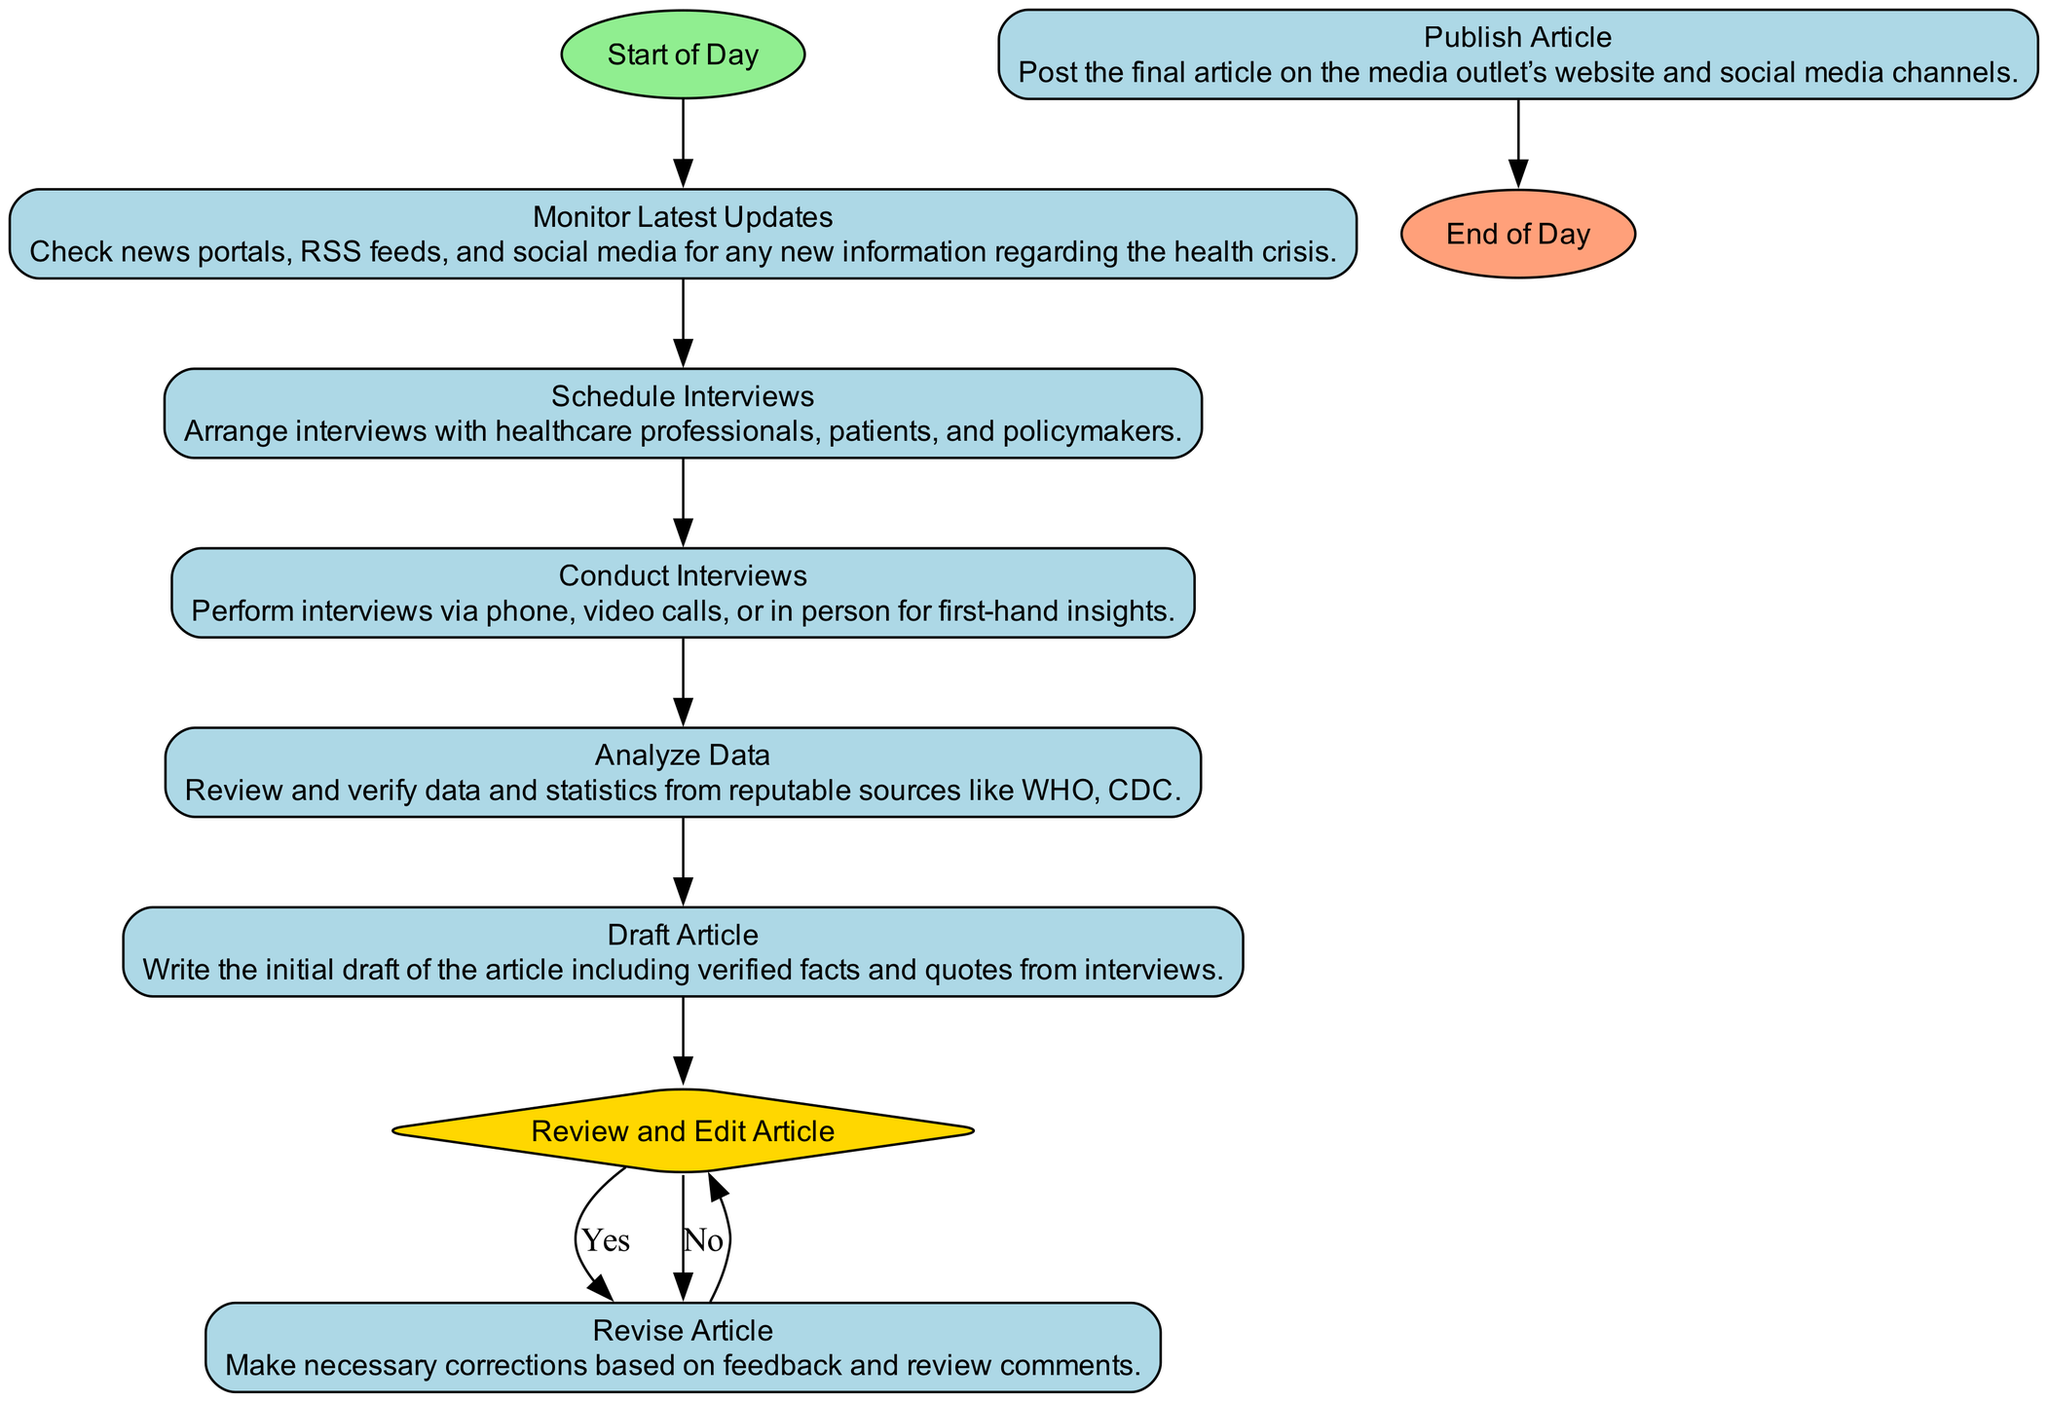What is the first activity in the diagram? The diagram starts with the "Start of Day" node, which indicates the beginning of the medical journalist's day. Hence, the first activity follows this starting point.
Answer: Start of Day How many activities are there in total? By counting each "Activity" type node in the diagram, we see that there are six activities: "Monitor Latest Updates," "Schedule Interviews," "Conduct Interviews," "Analyze Data," "Draft Article," and "Revise Article."
Answer: 6 What follows after "Analyze Data"? According to the flow of the diagram, after "Analyze Data," the next activity is "Draft Article." This indicates a sequential process where analysis leads to drafting.
Answer: Draft Article If the article needs revision, what is the next step? From the "Review and Edit Article" decision point, if the article needs revision, we go back to "Revise Article," indicating that revision is part of the editing process.
Answer: Revise Article What is the last action taken in the diagram? The terminal node of the diagram is "End of Day," which signifies that all activities have concluded. This represents the end point after publishing the article.
Answer: End of Day How many decision points are present in the diagram? There is only one decision point in the diagram, which is labeled "Review and Edit Article." This is where the decision to revise or approve the article occurs.
Answer: 1 What is the purpose of the "Conduct Interviews" activity? The "Conduct Interviews" activity serves to gather first-hand insights by performing interviews with various stakeholders, like healthcare professionals and patients. This provides depth to the article.
Answer: To perform interviews What action is taken after "Publish Article"? After "Publish Article," there are no further activities outlined, which means the next step is to conclude the day, leading directly to "End of Day." This indicates that publishing completes the journalist's tasks for the day.
Answer: End of Day What should be done if the article is approved after review? If the article is approved in the "Review and Edit Article" step, the next action is to "Publish Article," which involves disseminating the final work to the public through the media outlet.
Answer: Publish Article 